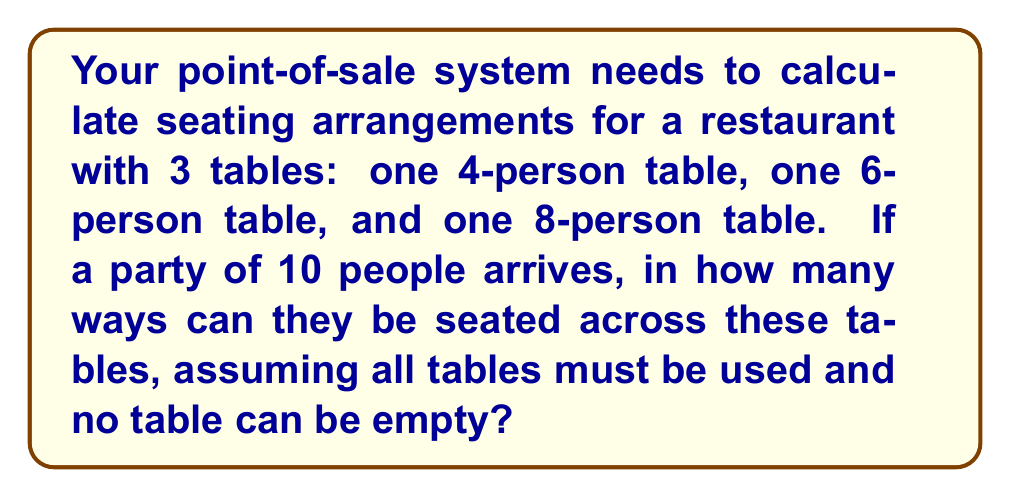Teach me how to tackle this problem. Let's approach this step-by-step:

1) We need to distribute 10 people among 3 tables, with each table having at least one person.

2) Let $x$, $y$, and $z$ represent the number of people at the 4-person, 6-person, and 8-person tables respectively.

3) We can set up the equation: $x + y + z = 10$, with constraints $1 \leq x \leq 4$, $1 \leq y \leq 6$, and $1 \leq z \leq 8$.

4) The possible combinations are:
   (1, 1, 8), (1, 2, 7), (1, 3, 6), (1, 4, 5), (2, 1, 7), (2, 2, 6), (2, 3, 5), (2, 4, 4),
   (3, 1, 6), (3, 2, 5), (3, 3, 4), (4, 1, 5), (4, 2, 4)

5) There are 13 ways to distribute the people among the tables.

6) For each distribution, we need to calculate the number of ways to arrange people at each table:
   - For a table with $n$ people, there are $n!$ ways to arrange them.

7) For each combination $(x, y, z)$, the number of arrangements is $x! \cdot y! \cdot z!$

8) The total number of arrangements is the sum of arrangements for all combinations:

   $$\sum_{(x,y,z)} x! \cdot y! \cdot z!$$

9) Calculating this sum:
   $$(1!1!8!) + (1!2!7!) + (1!3!6!) + (1!4!5!) + (2!1!7!) + (2!2!6!) + (2!3!5!) + (2!4!4!) +$$
   $$(3!1!6!) + (3!2!5!) + (3!3!4!) + (4!1!5!) + (4!2!4!)$$

10) Computing this sum yields 1,310,400 possible seating arrangements.
Answer: 1,310,400 